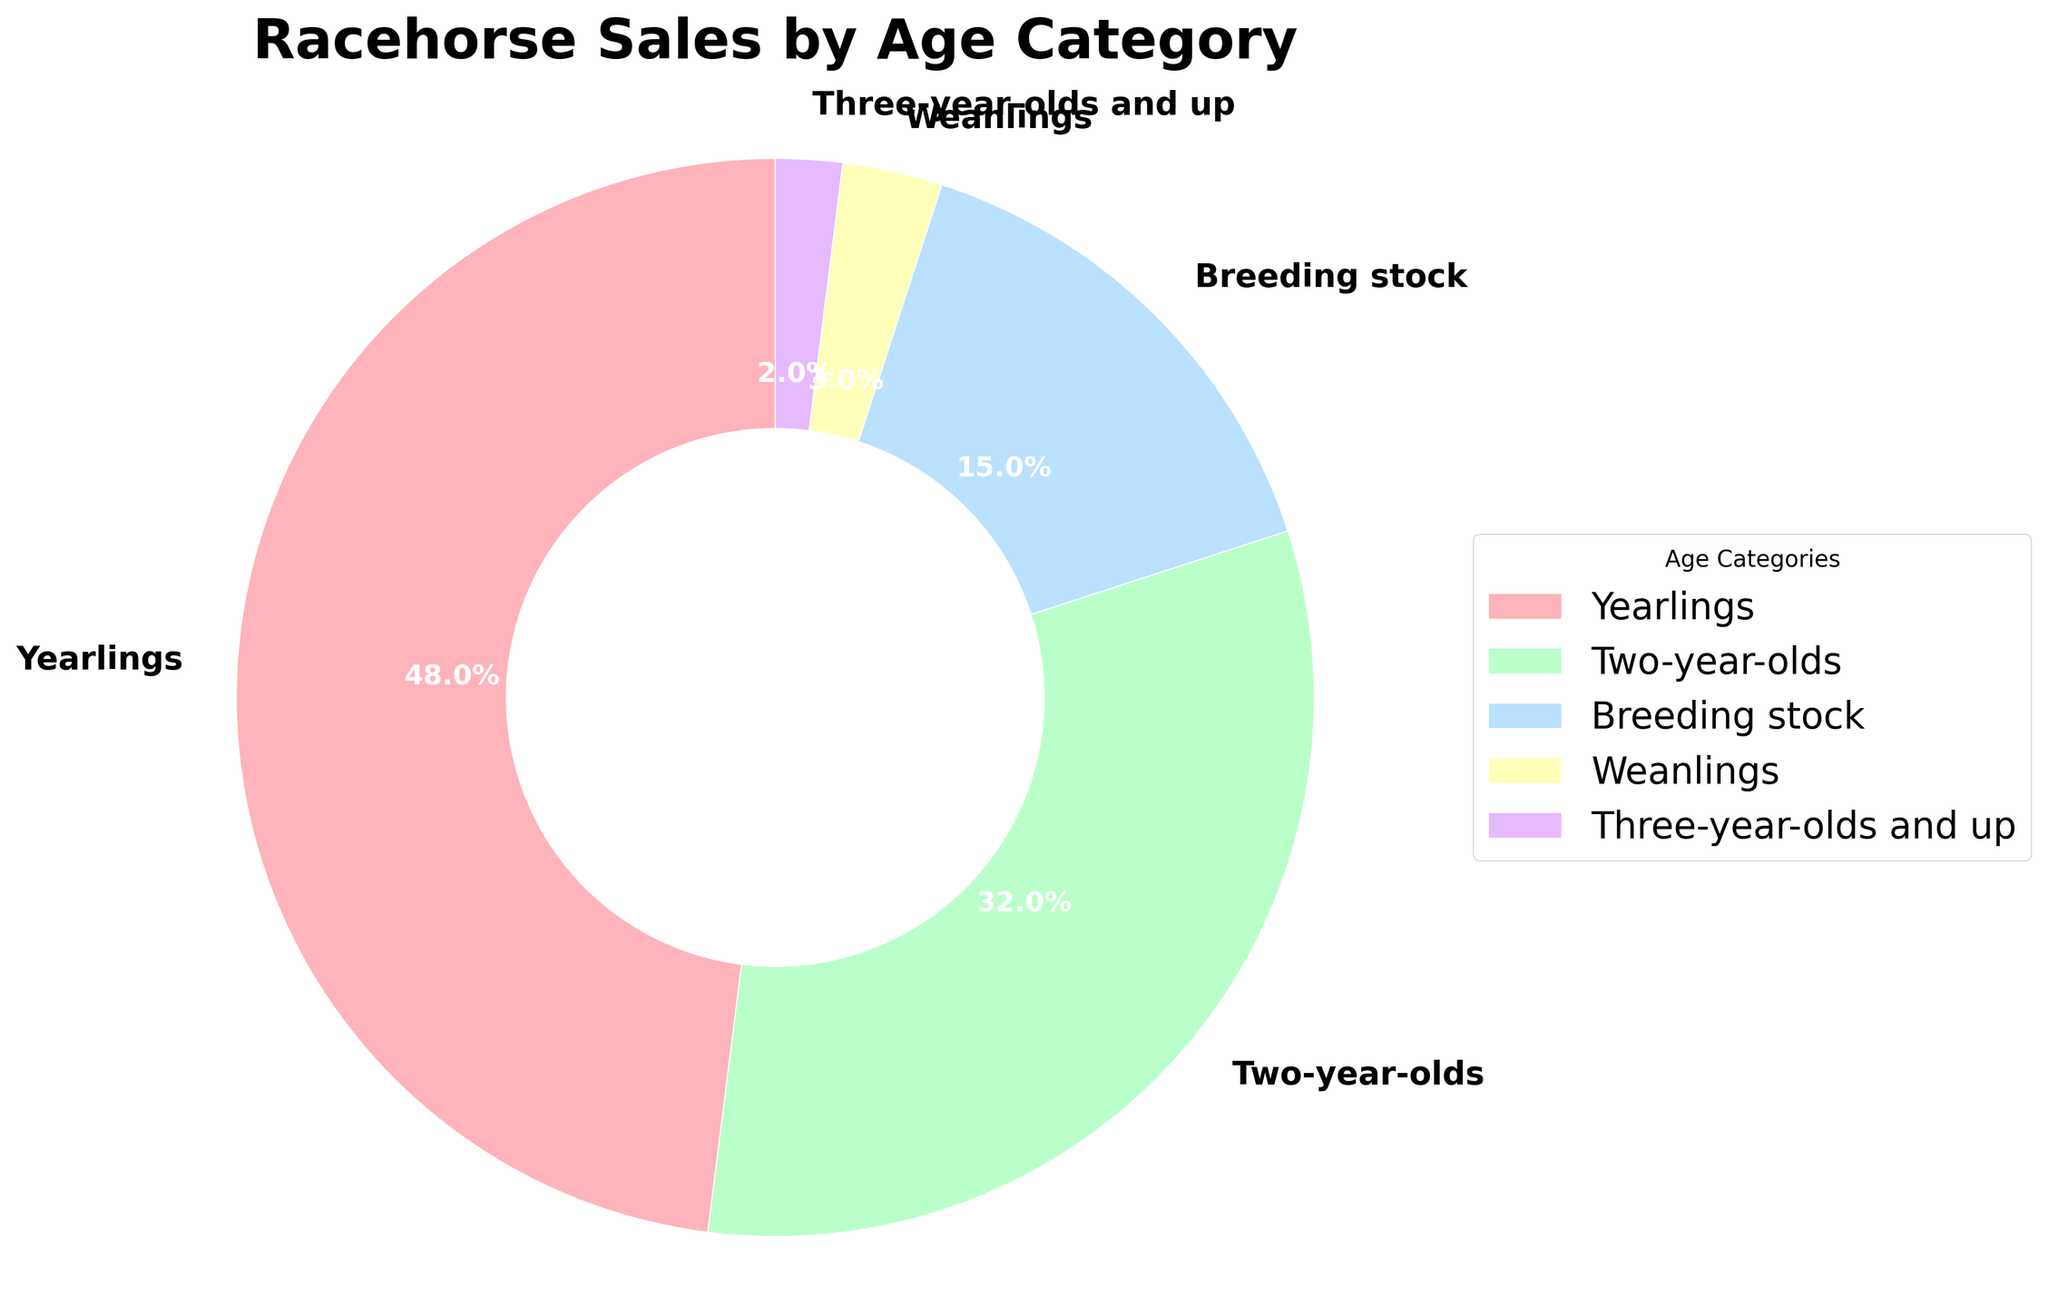What's the largest age category in the racehorse sales pie chart? The "Yearlings" section appears the largest visually. By reading the percentage labels, it's confirmed that "Yearlings" holds 48%, the highest percentage.
Answer: Yearlings Which two age categories combined constitute the majority of racehorse sales? Adding Yearlings (48%) and Two-year-olds (32%) gives 80%. Since 80% is more than 50%, these two categories together represent the majority.
Answer: Yearlings and Two-year-olds What is the difference in percentage between Yearlings and Breeding stock? Yearlings are at 48% and Breeding stock is at 15%. Subtracting these gives 48% - 15% = 33%.
Answer: 33% What percentage of racehorse sales is for Weanlings and Three-year-olds and up? Adding Weanlings (3%) and Three-year-olds and up (2%) gives 3% + 2% = 5%.
Answer: 5% Which category has the smallest percentage of racehorse sales? The visually smallest wedge and the smallest percentage label point to "Three-year-olds and up" at 2%.
Answer: Three-year-olds and up How does the percentage of Two-year-olds compare to Breeding stock? Two-year-olds are at 32%, and Breeding stock is at 15%. Since 32% is greater than 15%, Two-year-olds have a higher percentage.
Answer: Two-year-olds > Breeding stock If Breeding stock is combined with Weanlings and Three-year-olds and up, what is the total percentage? Adding Breeding stock (15%), Weanlings (3%), and Three-year-olds and up (2%) gives 15% + 3% + 2% = 20%.
Answer: 20% What is the percentage difference between Two-year-olds and Weanlings? Two-year-olds are at 32%, and Weanlings are at 3%. Subtracting these gives 32% - 3% = 29%.
Answer: 29% What is the ratio of Yearlings to Breeding stock in terms of percentage? Yearlings are at 48% and Breeding stock is at 15%. The ratio is 48% to 15%, which simplifies to 48/15 = 3.2.
Answer: 3.2:1 How much larger (in percentage points) is the Yearlings segment compared to Two-year-olds? Yearlings are at 48%, and Two-year-olds are at 32%. Subtracting these gives 48% - 32% = 16%.
Answer: 16% 